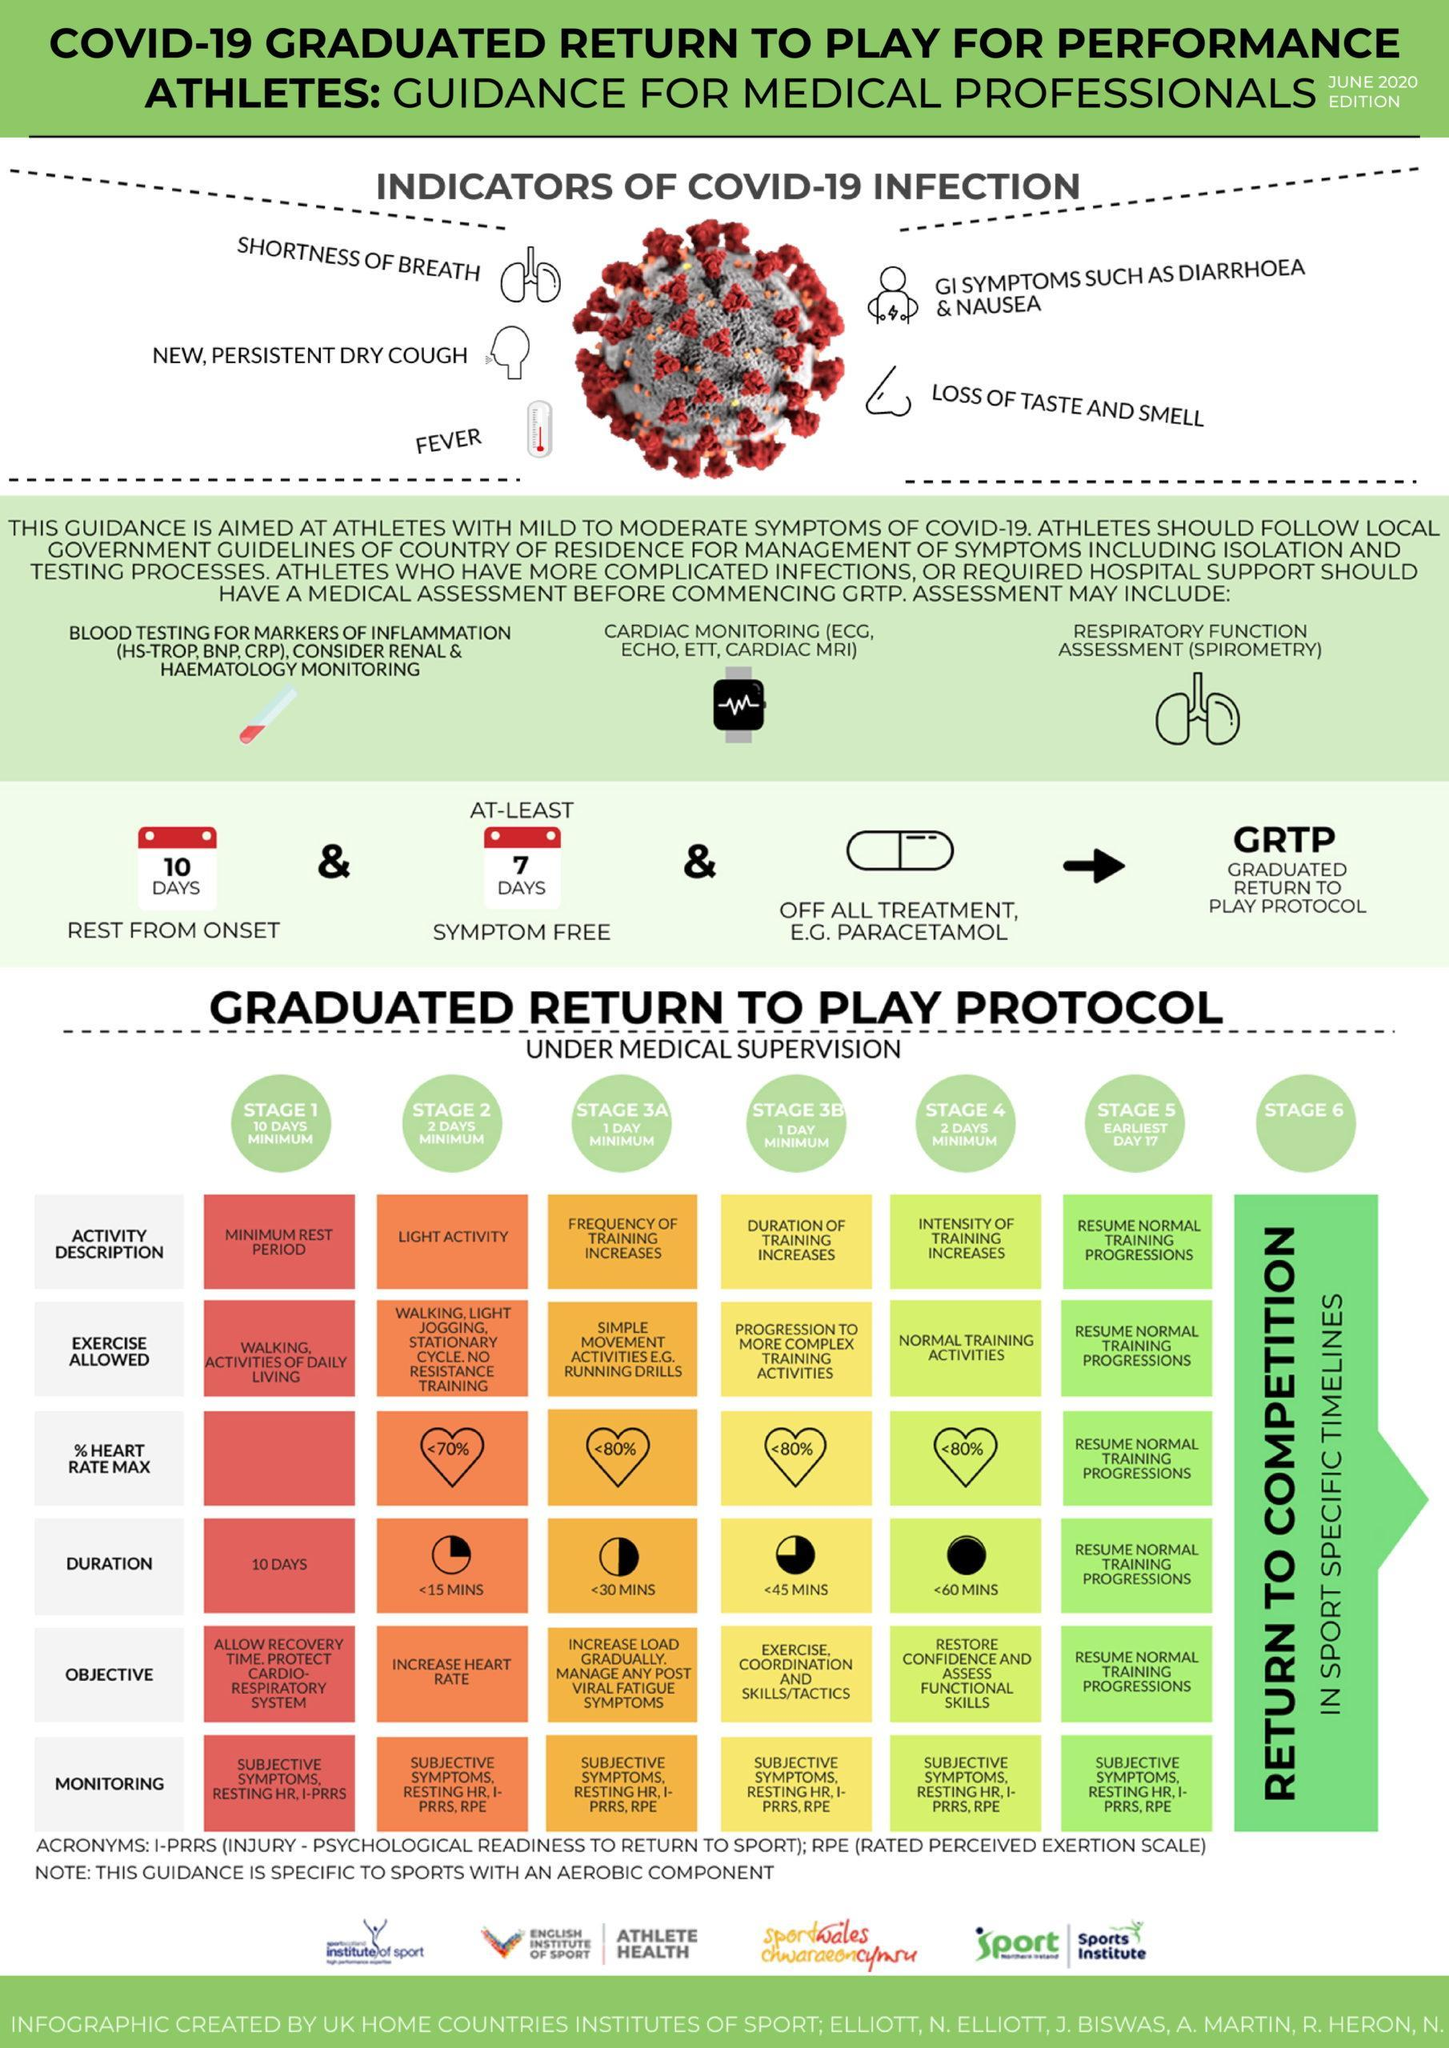What is the major symptom of Corona related to Nose and Tongue?
Answer the question with a short phrase. Loss of Taste and Smell For how long the person would not be having any indication of Corona? 7 days What is the third symptom of Covid-19? New, Persistent dry cough Which is the stage of Medical supervision where the graduate is free enough to return to normal life? Stage 6 How long is the Stage 4 supervision? 2 days minimum What is the color code given to schedule of Stage 1 - green, yellow, orange, red? red Which is the stage coloured in yellow? Stage 3B How many days the graduate will be kept for Stage 2 supervision? 2 days minimum How many different medical assessments are listed for people with complicated infections? 3 